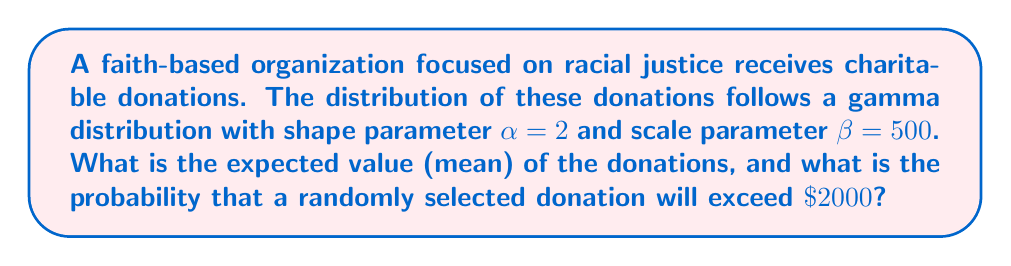Can you answer this question? To solve this problem, we need to understand the properties of the gamma distribution and how to calculate its mean and cumulative distribution function.

1. Expected Value (Mean):
For a gamma distribution with shape parameter $\alpha$ and scale parameter $\beta$, the expected value is given by:

$$ E[X] = \alpha \beta $$

In this case:
$$ E[X] = 2 \times 500 = 1000 $$

2. Probability of exceeding $2000:
We need to find $P(X > 2000)$. For a gamma distribution, it's often easier to find the complement probability $P(X \leq 2000)$ and then subtract from 1.

The cumulative distribution function (CDF) of a gamma distribution is given by the lower incomplete gamma function:

$$ P(X \leq x) = \frac{\gamma(\alpha, x/\beta)}{\Gamma(\alpha)} $$

Where $\gamma(\alpha, x)$ is the lower incomplete gamma function and $\Gamma(\alpha)$ is the gamma function.

We need to calculate:

$$ P(X > 2000) = 1 - P(X \leq 2000) = 1 - \frac{\gamma(2, 2000/500)}{\Gamma(2)} $$

This calculation is complex and typically requires numerical methods or statistical software. Using such tools, we find:

$$ P(X > 2000) \approx 0.1353 $$

This means there's approximately a 13.53% chance that a randomly selected donation will exceed $2000.
Answer: The expected value of donations is $1000. The probability that a randomly selected donation will exceed $2000 is approximately 0.1353 or 13.53%. 